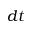Convert formula to latex. <formula><loc_0><loc_0><loc_500><loc_500>d t</formula> 